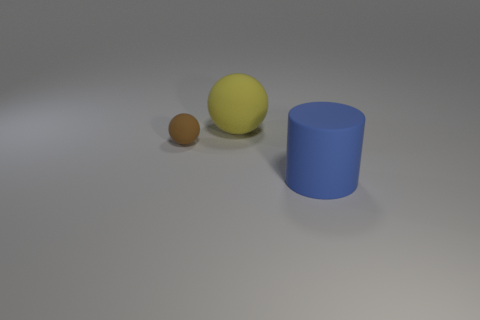Add 2 big gray matte blocks. How many objects exist? 5 Subtract all spheres. How many objects are left? 1 Subtract all yellow matte things. Subtract all tiny brown matte objects. How many objects are left? 1 Add 3 spheres. How many spheres are left? 5 Add 3 yellow matte objects. How many yellow matte objects exist? 4 Subtract 0 green blocks. How many objects are left? 3 